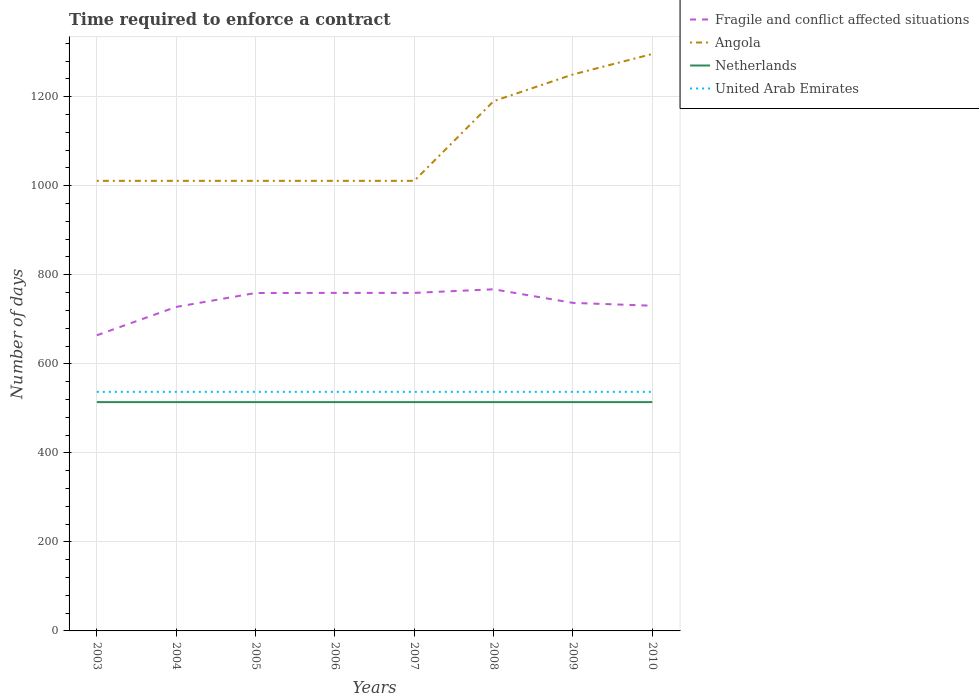Does the line corresponding to Angola intersect with the line corresponding to United Arab Emirates?
Keep it short and to the point. No. Is the number of lines equal to the number of legend labels?
Offer a terse response. Yes. Across all years, what is the maximum number of days required to enforce a contract in Fragile and conflict affected situations?
Offer a terse response. 664.11. What is the total number of days required to enforce a contract in Angola in the graph?
Your answer should be very brief. -60. Does the graph contain any zero values?
Ensure brevity in your answer.  No. Does the graph contain grids?
Give a very brief answer. Yes. Where does the legend appear in the graph?
Your response must be concise. Top right. How many legend labels are there?
Provide a short and direct response. 4. How are the legend labels stacked?
Offer a terse response. Vertical. What is the title of the graph?
Your response must be concise. Time required to enforce a contract. Does "Estonia" appear as one of the legend labels in the graph?
Ensure brevity in your answer.  No. What is the label or title of the Y-axis?
Offer a terse response. Number of days. What is the Number of days of Fragile and conflict affected situations in 2003?
Offer a terse response. 664.11. What is the Number of days in Angola in 2003?
Give a very brief answer. 1011. What is the Number of days of Netherlands in 2003?
Give a very brief answer. 514. What is the Number of days in United Arab Emirates in 2003?
Keep it short and to the point. 537. What is the Number of days of Fragile and conflict affected situations in 2004?
Make the answer very short. 727.8. What is the Number of days in Angola in 2004?
Make the answer very short. 1011. What is the Number of days in Netherlands in 2004?
Make the answer very short. 514. What is the Number of days of United Arab Emirates in 2004?
Give a very brief answer. 537. What is the Number of days in Fragile and conflict affected situations in 2005?
Provide a short and direct response. 759.07. What is the Number of days of Angola in 2005?
Your answer should be very brief. 1011. What is the Number of days in Netherlands in 2005?
Keep it short and to the point. 514. What is the Number of days in United Arab Emirates in 2005?
Ensure brevity in your answer.  537. What is the Number of days of Fragile and conflict affected situations in 2006?
Offer a very short reply. 759.34. What is the Number of days of Angola in 2006?
Your response must be concise. 1011. What is the Number of days of Netherlands in 2006?
Offer a terse response. 514. What is the Number of days of United Arab Emirates in 2006?
Offer a terse response. 537. What is the Number of days in Fragile and conflict affected situations in 2007?
Your response must be concise. 759.34. What is the Number of days of Angola in 2007?
Provide a succinct answer. 1011. What is the Number of days in Netherlands in 2007?
Your response must be concise. 514. What is the Number of days in United Arab Emirates in 2007?
Keep it short and to the point. 537. What is the Number of days in Fragile and conflict affected situations in 2008?
Provide a short and direct response. 767.41. What is the Number of days of Angola in 2008?
Offer a terse response. 1190. What is the Number of days in Netherlands in 2008?
Your answer should be compact. 514. What is the Number of days in United Arab Emirates in 2008?
Your response must be concise. 537. What is the Number of days in Fragile and conflict affected situations in 2009?
Offer a terse response. 736.87. What is the Number of days in Angola in 2009?
Offer a terse response. 1250. What is the Number of days in Netherlands in 2009?
Keep it short and to the point. 514. What is the Number of days in United Arab Emirates in 2009?
Make the answer very short. 537. What is the Number of days of Fragile and conflict affected situations in 2010?
Ensure brevity in your answer.  730.5. What is the Number of days of Angola in 2010?
Your answer should be compact. 1296. What is the Number of days of Netherlands in 2010?
Keep it short and to the point. 514. What is the Number of days of United Arab Emirates in 2010?
Make the answer very short. 537. Across all years, what is the maximum Number of days of Fragile and conflict affected situations?
Make the answer very short. 767.41. Across all years, what is the maximum Number of days of Angola?
Keep it short and to the point. 1296. Across all years, what is the maximum Number of days of Netherlands?
Provide a succinct answer. 514. Across all years, what is the maximum Number of days in United Arab Emirates?
Make the answer very short. 537. Across all years, what is the minimum Number of days in Fragile and conflict affected situations?
Provide a succinct answer. 664.11. Across all years, what is the minimum Number of days in Angola?
Your answer should be very brief. 1011. Across all years, what is the minimum Number of days in Netherlands?
Your response must be concise. 514. Across all years, what is the minimum Number of days of United Arab Emirates?
Ensure brevity in your answer.  537. What is the total Number of days of Fragile and conflict affected situations in the graph?
Provide a succinct answer. 5904.45. What is the total Number of days of Angola in the graph?
Keep it short and to the point. 8791. What is the total Number of days in Netherlands in the graph?
Make the answer very short. 4112. What is the total Number of days of United Arab Emirates in the graph?
Offer a very short reply. 4296. What is the difference between the Number of days of Fragile and conflict affected situations in 2003 and that in 2004?
Offer a terse response. -63.69. What is the difference between the Number of days of Angola in 2003 and that in 2004?
Give a very brief answer. 0. What is the difference between the Number of days of Fragile and conflict affected situations in 2003 and that in 2005?
Provide a short and direct response. -94.97. What is the difference between the Number of days of Angola in 2003 and that in 2005?
Offer a very short reply. 0. What is the difference between the Number of days in Netherlands in 2003 and that in 2005?
Your response must be concise. 0. What is the difference between the Number of days in Fragile and conflict affected situations in 2003 and that in 2006?
Make the answer very short. -95.24. What is the difference between the Number of days in Angola in 2003 and that in 2006?
Keep it short and to the point. 0. What is the difference between the Number of days of Netherlands in 2003 and that in 2006?
Ensure brevity in your answer.  0. What is the difference between the Number of days in United Arab Emirates in 2003 and that in 2006?
Provide a short and direct response. 0. What is the difference between the Number of days of Fragile and conflict affected situations in 2003 and that in 2007?
Give a very brief answer. -95.24. What is the difference between the Number of days of Netherlands in 2003 and that in 2007?
Provide a short and direct response. 0. What is the difference between the Number of days in United Arab Emirates in 2003 and that in 2007?
Your answer should be compact. 0. What is the difference between the Number of days in Fragile and conflict affected situations in 2003 and that in 2008?
Offer a very short reply. -103.31. What is the difference between the Number of days in Angola in 2003 and that in 2008?
Make the answer very short. -179. What is the difference between the Number of days in United Arab Emirates in 2003 and that in 2008?
Offer a terse response. 0. What is the difference between the Number of days in Fragile and conflict affected situations in 2003 and that in 2009?
Your answer should be compact. -72.76. What is the difference between the Number of days of Angola in 2003 and that in 2009?
Your answer should be very brief. -239. What is the difference between the Number of days of Netherlands in 2003 and that in 2009?
Offer a terse response. 0. What is the difference between the Number of days in Fragile and conflict affected situations in 2003 and that in 2010?
Offer a very short reply. -66.39. What is the difference between the Number of days of Angola in 2003 and that in 2010?
Offer a terse response. -285. What is the difference between the Number of days of Netherlands in 2003 and that in 2010?
Keep it short and to the point. 0. What is the difference between the Number of days in Fragile and conflict affected situations in 2004 and that in 2005?
Keep it short and to the point. -31.27. What is the difference between the Number of days of Fragile and conflict affected situations in 2004 and that in 2006?
Offer a very short reply. -31.54. What is the difference between the Number of days in Angola in 2004 and that in 2006?
Make the answer very short. 0. What is the difference between the Number of days of Fragile and conflict affected situations in 2004 and that in 2007?
Keep it short and to the point. -31.54. What is the difference between the Number of days in Angola in 2004 and that in 2007?
Keep it short and to the point. 0. What is the difference between the Number of days of United Arab Emirates in 2004 and that in 2007?
Your answer should be very brief. 0. What is the difference between the Number of days of Fragile and conflict affected situations in 2004 and that in 2008?
Keep it short and to the point. -39.61. What is the difference between the Number of days of Angola in 2004 and that in 2008?
Ensure brevity in your answer.  -179. What is the difference between the Number of days of Netherlands in 2004 and that in 2008?
Make the answer very short. 0. What is the difference between the Number of days of United Arab Emirates in 2004 and that in 2008?
Make the answer very short. 0. What is the difference between the Number of days in Fragile and conflict affected situations in 2004 and that in 2009?
Your response must be concise. -9.07. What is the difference between the Number of days of Angola in 2004 and that in 2009?
Offer a terse response. -239. What is the difference between the Number of days of Netherlands in 2004 and that in 2009?
Provide a short and direct response. 0. What is the difference between the Number of days of United Arab Emirates in 2004 and that in 2009?
Provide a succinct answer. 0. What is the difference between the Number of days in Angola in 2004 and that in 2010?
Provide a short and direct response. -285. What is the difference between the Number of days of United Arab Emirates in 2004 and that in 2010?
Give a very brief answer. 0. What is the difference between the Number of days in Fragile and conflict affected situations in 2005 and that in 2006?
Make the answer very short. -0.27. What is the difference between the Number of days of Netherlands in 2005 and that in 2006?
Provide a succinct answer. 0. What is the difference between the Number of days in United Arab Emirates in 2005 and that in 2006?
Provide a succinct answer. 0. What is the difference between the Number of days of Fragile and conflict affected situations in 2005 and that in 2007?
Make the answer very short. -0.27. What is the difference between the Number of days in Angola in 2005 and that in 2007?
Make the answer very short. 0. What is the difference between the Number of days of Netherlands in 2005 and that in 2007?
Your answer should be very brief. 0. What is the difference between the Number of days in Fragile and conflict affected situations in 2005 and that in 2008?
Your answer should be compact. -8.34. What is the difference between the Number of days of Angola in 2005 and that in 2008?
Keep it short and to the point. -179. What is the difference between the Number of days of Fragile and conflict affected situations in 2005 and that in 2009?
Give a very brief answer. 22.2. What is the difference between the Number of days of Angola in 2005 and that in 2009?
Offer a very short reply. -239. What is the difference between the Number of days in Netherlands in 2005 and that in 2009?
Give a very brief answer. 0. What is the difference between the Number of days in United Arab Emirates in 2005 and that in 2009?
Provide a short and direct response. 0. What is the difference between the Number of days in Fragile and conflict affected situations in 2005 and that in 2010?
Make the answer very short. 28.57. What is the difference between the Number of days of Angola in 2005 and that in 2010?
Your response must be concise. -285. What is the difference between the Number of days of Angola in 2006 and that in 2007?
Offer a very short reply. 0. What is the difference between the Number of days of Fragile and conflict affected situations in 2006 and that in 2008?
Your answer should be very brief. -8.07. What is the difference between the Number of days of Angola in 2006 and that in 2008?
Your response must be concise. -179. What is the difference between the Number of days of United Arab Emirates in 2006 and that in 2008?
Your answer should be compact. 0. What is the difference between the Number of days of Fragile and conflict affected situations in 2006 and that in 2009?
Make the answer very short. 22.48. What is the difference between the Number of days in Angola in 2006 and that in 2009?
Provide a short and direct response. -239. What is the difference between the Number of days in United Arab Emirates in 2006 and that in 2009?
Offer a very short reply. 0. What is the difference between the Number of days of Fragile and conflict affected situations in 2006 and that in 2010?
Offer a very short reply. 28.84. What is the difference between the Number of days in Angola in 2006 and that in 2010?
Your answer should be very brief. -285. What is the difference between the Number of days of Fragile and conflict affected situations in 2007 and that in 2008?
Provide a short and direct response. -8.07. What is the difference between the Number of days in Angola in 2007 and that in 2008?
Provide a short and direct response. -179. What is the difference between the Number of days of Netherlands in 2007 and that in 2008?
Your answer should be very brief. 0. What is the difference between the Number of days in Fragile and conflict affected situations in 2007 and that in 2009?
Your answer should be compact. 22.48. What is the difference between the Number of days of Angola in 2007 and that in 2009?
Your answer should be very brief. -239. What is the difference between the Number of days of Netherlands in 2007 and that in 2009?
Ensure brevity in your answer.  0. What is the difference between the Number of days in Fragile and conflict affected situations in 2007 and that in 2010?
Ensure brevity in your answer.  28.84. What is the difference between the Number of days of Angola in 2007 and that in 2010?
Offer a very short reply. -285. What is the difference between the Number of days in Fragile and conflict affected situations in 2008 and that in 2009?
Your response must be concise. 30.55. What is the difference between the Number of days in Angola in 2008 and that in 2009?
Ensure brevity in your answer.  -60. What is the difference between the Number of days of Netherlands in 2008 and that in 2009?
Make the answer very short. 0. What is the difference between the Number of days of Fragile and conflict affected situations in 2008 and that in 2010?
Your response must be concise. 36.91. What is the difference between the Number of days in Angola in 2008 and that in 2010?
Offer a very short reply. -106. What is the difference between the Number of days in United Arab Emirates in 2008 and that in 2010?
Your response must be concise. 0. What is the difference between the Number of days in Fragile and conflict affected situations in 2009 and that in 2010?
Give a very brief answer. 6.37. What is the difference between the Number of days in Angola in 2009 and that in 2010?
Make the answer very short. -46. What is the difference between the Number of days in Fragile and conflict affected situations in 2003 and the Number of days in Angola in 2004?
Your answer should be very brief. -346.89. What is the difference between the Number of days in Fragile and conflict affected situations in 2003 and the Number of days in Netherlands in 2004?
Offer a terse response. 150.11. What is the difference between the Number of days in Fragile and conflict affected situations in 2003 and the Number of days in United Arab Emirates in 2004?
Keep it short and to the point. 127.11. What is the difference between the Number of days in Angola in 2003 and the Number of days in Netherlands in 2004?
Your answer should be very brief. 497. What is the difference between the Number of days of Angola in 2003 and the Number of days of United Arab Emirates in 2004?
Make the answer very short. 474. What is the difference between the Number of days of Netherlands in 2003 and the Number of days of United Arab Emirates in 2004?
Ensure brevity in your answer.  -23. What is the difference between the Number of days of Fragile and conflict affected situations in 2003 and the Number of days of Angola in 2005?
Keep it short and to the point. -346.89. What is the difference between the Number of days in Fragile and conflict affected situations in 2003 and the Number of days in Netherlands in 2005?
Ensure brevity in your answer.  150.11. What is the difference between the Number of days in Fragile and conflict affected situations in 2003 and the Number of days in United Arab Emirates in 2005?
Offer a very short reply. 127.11. What is the difference between the Number of days of Angola in 2003 and the Number of days of Netherlands in 2005?
Provide a short and direct response. 497. What is the difference between the Number of days in Angola in 2003 and the Number of days in United Arab Emirates in 2005?
Ensure brevity in your answer.  474. What is the difference between the Number of days of Fragile and conflict affected situations in 2003 and the Number of days of Angola in 2006?
Give a very brief answer. -346.89. What is the difference between the Number of days of Fragile and conflict affected situations in 2003 and the Number of days of Netherlands in 2006?
Your response must be concise. 150.11. What is the difference between the Number of days in Fragile and conflict affected situations in 2003 and the Number of days in United Arab Emirates in 2006?
Give a very brief answer. 127.11. What is the difference between the Number of days in Angola in 2003 and the Number of days in Netherlands in 2006?
Offer a very short reply. 497. What is the difference between the Number of days in Angola in 2003 and the Number of days in United Arab Emirates in 2006?
Ensure brevity in your answer.  474. What is the difference between the Number of days of Netherlands in 2003 and the Number of days of United Arab Emirates in 2006?
Keep it short and to the point. -23. What is the difference between the Number of days of Fragile and conflict affected situations in 2003 and the Number of days of Angola in 2007?
Your answer should be compact. -346.89. What is the difference between the Number of days in Fragile and conflict affected situations in 2003 and the Number of days in Netherlands in 2007?
Your response must be concise. 150.11. What is the difference between the Number of days of Fragile and conflict affected situations in 2003 and the Number of days of United Arab Emirates in 2007?
Your answer should be compact. 127.11. What is the difference between the Number of days of Angola in 2003 and the Number of days of Netherlands in 2007?
Offer a very short reply. 497. What is the difference between the Number of days of Angola in 2003 and the Number of days of United Arab Emirates in 2007?
Your answer should be very brief. 474. What is the difference between the Number of days of Fragile and conflict affected situations in 2003 and the Number of days of Angola in 2008?
Make the answer very short. -525.89. What is the difference between the Number of days of Fragile and conflict affected situations in 2003 and the Number of days of Netherlands in 2008?
Offer a very short reply. 150.11. What is the difference between the Number of days of Fragile and conflict affected situations in 2003 and the Number of days of United Arab Emirates in 2008?
Give a very brief answer. 127.11. What is the difference between the Number of days of Angola in 2003 and the Number of days of Netherlands in 2008?
Your answer should be compact. 497. What is the difference between the Number of days in Angola in 2003 and the Number of days in United Arab Emirates in 2008?
Keep it short and to the point. 474. What is the difference between the Number of days in Netherlands in 2003 and the Number of days in United Arab Emirates in 2008?
Make the answer very short. -23. What is the difference between the Number of days of Fragile and conflict affected situations in 2003 and the Number of days of Angola in 2009?
Offer a terse response. -585.89. What is the difference between the Number of days in Fragile and conflict affected situations in 2003 and the Number of days in Netherlands in 2009?
Offer a terse response. 150.11. What is the difference between the Number of days of Fragile and conflict affected situations in 2003 and the Number of days of United Arab Emirates in 2009?
Give a very brief answer. 127.11. What is the difference between the Number of days of Angola in 2003 and the Number of days of Netherlands in 2009?
Keep it short and to the point. 497. What is the difference between the Number of days of Angola in 2003 and the Number of days of United Arab Emirates in 2009?
Give a very brief answer. 474. What is the difference between the Number of days in Netherlands in 2003 and the Number of days in United Arab Emirates in 2009?
Give a very brief answer. -23. What is the difference between the Number of days in Fragile and conflict affected situations in 2003 and the Number of days in Angola in 2010?
Keep it short and to the point. -631.89. What is the difference between the Number of days of Fragile and conflict affected situations in 2003 and the Number of days of Netherlands in 2010?
Keep it short and to the point. 150.11. What is the difference between the Number of days of Fragile and conflict affected situations in 2003 and the Number of days of United Arab Emirates in 2010?
Offer a very short reply. 127.11. What is the difference between the Number of days of Angola in 2003 and the Number of days of Netherlands in 2010?
Your answer should be very brief. 497. What is the difference between the Number of days of Angola in 2003 and the Number of days of United Arab Emirates in 2010?
Offer a very short reply. 474. What is the difference between the Number of days in Fragile and conflict affected situations in 2004 and the Number of days in Angola in 2005?
Offer a very short reply. -283.2. What is the difference between the Number of days of Fragile and conflict affected situations in 2004 and the Number of days of Netherlands in 2005?
Provide a succinct answer. 213.8. What is the difference between the Number of days in Fragile and conflict affected situations in 2004 and the Number of days in United Arab Emirates in 2005?
Offer a very short reply. 190.8. What is the difference between the Number of days in Angola in 2004 and the Number of days in Netherlands in 2005?
Your answer should be very brief. 497. What is the difference between the Number of days of Angola in 2004 and the Number of days of United Arab Emirates in 2005?
Your response must be concise. 474. What is the difference between the Number of days of Fragile and conflict affected situations in 2004 and the Number of days of Angola in 2006?
Your response must be concise. -283.2. What is the difference between the Number of days of Fragile and conflict affected situations in 2004 and the Number of days of Netherlands in 2006?
Offer a very short reply. 213.8. What is the difference between the Number of days of Fragile and conflict affected situations in 2004 and the Number of days of United Arab Emirates in 2006?
Provide a short and direct response. 190.8. What is the difference between the Number of days in Angola in 2004 and the Number of days in Netherlands in 2006?
Provide a short and direct response. 497. What is the difference between the Number of days of Angola in 2004 and the Number of days of United Arab Emirates in 2006?
Your answer should be compact. 474. What is the difference between the Number of days of Fragile and conflict affected situations in 2004 and the Number of days of Angola in 2007?
Provide a short and direct response. -283.2. What is the difference between the Number of days in Fragile and conflict affected situations in 2004 and the Number of days in Netherlands in 2007?
Provide a short and direct response. 213.8. What is the difference between the Number of days of Fragile and conflict affected situations in 2004 and the Number of days of United Arab Emirates in 2007?
Offer a very short reply. 190.8. What is the difference between the Number of days of Angola in 2004 and the Number of days of Netherlands in 2007?
Your answer should be very brief. 497. What is the difference between the Number of days in Angola in 2004 and the Number of days in United Arab Emirates in 2007?
Make the answer very short. 474. What is the difference between the Number of days of Netherlands in 2004 and the Number of days of United Arab Emirates in 2007?
Offer a terse response. -23. What is the difference between the Number of days of Fragile and conflict affected situations in 2004 and the Number of days of Angola in 2008?
Provide a succinct answer. -462.2. What is the difference between the Number of days in Fragile and conflict affected situations in 2004 and the Number of days in Netherlands in 2008?
Your answer should be very brief. 213.8. What is the difference between the Number of days in Fragile and conflict affected situations in 2004 and the Number of days in United Arab Emirates in 2008?
Offer a very short reply. 190.8. What is the difference between the Number of days of Angola in 2004 and the Number of days of Netherlands in 2008?
Your answer should be compact. 497. What is the difference between the Number of days in Angola in 2004 and the Number of days in United Arab Emirates in 2008?
Keep it short and to the point. 474. What is the difference between the Number of days of Fragile and conflict affected situations in 2004 and the Number of days of Angola in 2009?
Your response must be concise. -522.2. What is the difference between the Number of days of Fragile and conflict affected situations in 2004 and the Number of days of Netherlands in 2009?
Your answer should be very brief. 213.8. What is the difference between the Number of days in Fragile and conflict affected situations in 2004 and the Number of days in United Arab Emirates in 2009?
Your response must be concise. 190.8. What is the difference between the Number of days in Angola in 2004 and the Number of days in Netherlands in 2009?
Your answer should be very brief. 497. What is the difference between the Number of days in Angola in 2004 and the Number of days in United Arab Emirates in 2009?
Your response must be concise. 474. What is the difference between the Number of days in Fragile and conflict affected situations in 2004 and the Number of days in Angola in 2010?
Your response must be concise. -568.2. What is the difference between the Number of days of Fragile and conflict affected situations in 2004 and the Number of days of Netherlands in 2010?
Provide a succinct answer. 213.8. What is the difference between the Number of days in Fragile and conflict affected situations in 2004 and the Number of days in United Arab Emirates in 2010?
Your answer should be very brief. 190.8. What is the difference between the Number of days in Angola in 2004 and the Number of days in Netherlands in 2010?
Keep it short and to the point. 497. What is the difference between the Number of days in Angola in 2004 and the Number of days in United Arab Emirates in 2010?
Offer a terse response. 474. What is the difference between the Number of days of Netherlands in 2004 and the Number of days of United Arab Emirates in 2010?
Keep it short and to the point. -23. What is the difference between the Number of days in Fragile and conflict affected situations in 2005 and the Number of days in Angola in 2006?
Offer a very short reply. -251.93. What is the difference between the Number of days of Fragile and conflict affected situations in 2005 and the Number of days of Netherlands in 2006?
Your answer should be compact. 245.07. What is the difference between the Number of days in Fragile and conflict affected situations in 2005 and the Number of days in United Arab Emirates in 2006?
Offer a terse response. 222.07. What is the difference between the Number of days of Angola in 2005 and the Number of days of Netherlands in 2006?
Give a very brief answer. 497. What is the difference between the Number of days of Angola in 2005 and the Number of days of United Arab Emirates in 2006?
Give a very brief answer. 474. What is the difference between the Number of days of Netherlands in 2005 and the Number of days of United Arab Emirates in 2006?
Provide a short and direct response. -23. What is the difference between the Number of days in Fragile and conflict affected situations in 2005 and the Number of days in Angola in 2007?
Provide a short and direct response. -251.93. What is the difference between the Number of days of Fragile and conflict affected situations in 2005 and the Number of days of Netherlands in 2007?
Ensure brevity in your answer.  245.07. What is the difference between the Number of days of Fragile and conflict affected situations in 2005 and the Number of days of United Arab Emirates in 2007?
Provide a short and direct response. 222.07. What is the difference between the Number of days of Angola in 2005 and the Number of days of Netherlands in 2007?
Your answer should be very brief. 497. What is the difference between the Number of days in Angola in 2005 and the Number of days in United Arab Emirates in 2007?
Provide a succinct answer. 474. What is the difference between the Number of days of Fragile and conflict affected situations in 2005 and the Number of days of Angola in 2008?
Ensure brevity in your answer.  -430.93. What is the difference between the Number of days in Fragile and conflict affected situations in 2005 and the Number of days in Netherlands in 2008?
Your answer should be compact. 245.07. What is the difference between the Number of days of Fragile and conflict affected situations in 2005 and the Number of days of United Arab Emirates in 2008?
Offer a very short reply. 222.07. What is the difference between the Number of days of Angola in 2005 and the Number of days of Netherlands in 2008?
Provide a succinct answer. 497. What is the difference between the Number of days in Angola in 2005 and the Number of days in United Arab Emirates in 2008?
Give a very brief answer. 474. What is the difference between the Number of days of Netherlands in 2005 and the Number of days of United Arab Emirates in 2008?
Provide a succinct answer. -23. What is the difference between the Number of days of Fragile and conflict affected situations in 2005 and the Number of days of Angola in 2009?
Your response must be concise. -490.93. What is the difference between the Number of days in Fragile and conflict affected situations in 2005 and the Number of days in Netherlands in 2009?
Your answer should be compact. 245.07. What is the difference between the Number of days in Fragile and conflict affected situations in 2005 and the Number of days in United Arab Emirates in 2009?
Keep it short and to the point. 222.07. What is the difference between the Number of days in Angola in 2005 and the Number of days in Netherlands in 2009?
Provide a succinct answer. 497. What is the difference between the Number of days in Angola in 2005 and the Number of days in United Arab Emirates in 2009?
Your answer should be compact. 474. What is the difference between the Number of days in Netherlands in 2005 and the Number of days in United Arab Emirates in 2009?
Ensure brevity in your answer.  -23. What is the difference between the Number of days in Fragile and conflict affected situations in 2005 and the Number of days in Angola in 2010?
Your answer should be very brief. -536.93. What is the difference between the Number of days in Fragile and conflict affected situations in 2005 and the Number of days in Netherlands in 2010?
Provide a succinct answer. 245.07. What is the difference between the Number of days of Fragile and conflict affected situations in 2005 and the Number of days of United Arab Emirates in 2010?
Offer a terse response. 222.07. What is the difference between the Number of days in Angola in 2005 and the Number of days in Netherlands in 2010?
Your answer should be very brief. 497. What is the difference between the Number of days in Angola in 2005 and the Number of days in United Arab Emirates in 2010?
Your answer should be very brief. 474. What is the difference between the Number of days in Netherlands in 2005 and the Number of days in United Arab Emirates in 2010?
Give a very brief answer. -23. What is the difference between the Number of days in Fragile and conflict affected situations in 2006 and the Number of days in Angola in 2007?
Provide a succinct answer. -251.66. What is the difference between the Number of days in Fragile and conflict affected situations in 2006 and the Number of days in Netherlands in 2007?
Offer a very short reply. 245.34. What is the difference between the Number of days of Fragile and conflict affected situations in 2006 and the Number of days of United Arab Emirates in 2007?
Your answer should be very brief. 222.34. What is the difference between the Number of days in Angola in 2006 and the Number of days in Netherlands in 2007?
Offer a terse response. 497. What is the difference between the Number of days in Angola in 2006 and the Number of days in United Arab Emirates in 2007?
Keep it short and to the point. 474. What is the difference between the Number of days in Netherlands in 2006 and the Number of days in United Arab Emirates in 2007?
Keep it short and to the point. -23. What is the difference between the Number of days in Fragile and conflict affected situations in 2006 and the Number of days in Angola in 2008?
Your answer should be compact. -430.66. What is the difference between the Number of days of Fragile and conflict affected situations in 2006 and the Number of days of Netherlands in 2008?
Offer a terse response. 245.34. What is the difference between the Number of days of Fragile and conflict affected situations in 2006 and the Number of days of United Arab Emirates in 2008?
Give a very brief answer. 222.34. What is the difference between the Number of days in Angola in 2006 and the Number of days in Netherlands in 2008?
Make the answer very short. 497. What is the difference between the Number of days of Angola in 2006 and the Number of days of United Arab Emirates in 2008?
Give a very brief answer. 474. What is the difference between the Number of days in Fragile and conflict affected situations in 2006 and the Number of days in Angola in 2009?
Give a very brief answer. -490.66. What is the difference between the Number of days in Fragile and conflict affected situations in 2006 and the Number of days in Netherlands in 2009?
Make the answer very short. 245.34. What is the difference between the Number of days of Fragile and conflict affected situations in 2006 and the Number of days of United Arab Emirates in 2009?
Ensure brevity in your answer.  222.34. What is the difference between the Number of days in Angola in 2006 and the Number of days in Netherlands in 2009?
Offer a very short reply. 497. What is the difference between the Number of days of Angola in 2006 and the Number of days of United Arab Emirates in 2009?
Give a very brief answer. 474. What is the difference between the Number of days in Fragile and conflict affected situations in 2006 and the Number of days in Angola in 2010?
Your response must be concise. -536.66. What is the difference between the Number of days of Fragile and conflict affected situations in 2006 and the Number of days of Netherlands in 2010?
Ensure brevity in your answer.  245.34. What is the difference between the Number of days of Fragile and conflict affected situations in 2006 and the Number of days of United Arab Emirates in 2010?
Your answer should be very brief. 222.34. What is the difference between the Number of days in Angola in 2006 and the Number of days in Netherlands in 2010?
Offer a very short reply. 497. What is the difference between the Number of days of Angola in 2006 and the Number of days of United Arab Emirates in 2010?
Provide a succinct answer. 474. What is the difference between the Number of days in Netherlands in 2006 and the Number of days in United Arab Emirates in 2010?
Make the answer very short. -23. What is the difference between the Number of days in Fragile and conflict affected situations in 2007 and the Number of days in Angola in 2008?
Offer a terse response. -430.66. What is the difference between the Number of days of Fragile and conflict affected situations in 2007 and the Number of days of Netherlands in 2008?
Ensure brevity in your answer.  245.34. What is the difference between the Number of days of Fragile and conflict affected situations in 2007 and the Number of days of United Arab Emirates in 2008?
Your answer should be very brief. 222.34. What is the difference between the Number of days in Angola in 2007 and the Number of days in Netherlands in 2008?
Make the answer very short. 497. What is the difference between the Number of days of Angola in 2007 and the Number of days of United Arab Emirates in 2008?
Provide a short and direct response. 474. What is the difference between the Number of days of Netherlands in 2007 and the Number of days of United Arab Emirates in 2008?
Make the answer very short. -23. What is the difference between the Number of days in Fragile and conflict affected situations in 2007 and the Number of days in Angola in 2009?
Your answer should be very brief. -490.66. What is the difference between the Number of days of Fragile and conflict affected situations in 2007 and the Number of days of Netherlands in 2009?
Provide a succinct answer. 245.34. What is the difference between the Number of days in Fragile and conflict affected situations in 2007 and the Number of days in United Arab Emirates in 2009?
Offer a very short reply. 222.34. What is the difference between the Number of days in Angola in 2007 and the Number of days in Netherlands in 2009?
Keep it short and to the point. 497. What is the difference between the Number of days of Angola in 2007 and the Number of days of United Arab Emirates in 2009?
Ensure brevity in your answer.  474. What is the difference between the Number of days of Fragile and conflict affected situations in 2007 and the Number of days of Angola in 2010?
Ensure brevity in your answer.  -536.66. What is the difference between the Number of days in Fragile and conflict affected situations in 2007 and the Number of days in Netherlands in 2010?
Provide a succinct answer. 245.34. What is the difference between the Number of days of Fragile and conflict affected situations in 2007 and the Number of days of United Arab Emirates in 2010?
Provide a succinct answer. 222.34. What is the difference between the Number of days in Angola in 2007 and the Number of days in Netherlands in 2010?
Ensure brevity in your answer.  497. What is the difference between the Number of days in Angola in 2007 and the Number of days in United Arab Emirates in 2010?
Provide a short and direct response. 474. What is the difference between the Number of days of Netherlands in 2007 and the Number of days of United Arab Emirates in 2010?
Offer a very short reply. -23. What is the difference between the Number of days of Fragile and conflict affected situations in 2008 and the Number of days of Angola in 2009?
Make the answer very short. -482.59. What is the difference between the Number of days of Fragile and conflict affected situations in 2008 and the Number of days of Netherlands in 2009?
Give a very brief answer. 253.41. What is the difference between the Number of days of Fragile and conflict affected situations in 2008 and the Number of days of United Arab Emirates in 2009?
Keep it short and to the point. 230.41. What is the difference between the Number of days in Angola in 2008 and the Number of days in Netherlands in 2009?
Provide a succinct answer. 676. What is the difference between the Number of days in Angola in 2008 and the Number of days in United Arab Emirates in 2009?
Your response must be concise. 653. What is the difference between the Number of days of Fragile and conflict affected situations in 2008 and the Number of days of Angola in 2010?
Ensure brevity in your answer.  -528.59. What is the difference between the Number of days in Fragile and conflict affected situations in 2008 and the Number of days in Netherlands in 2010?
Ensure brevity in your answer.  253.41. What is the difference between the Number of days in Fragile and conflict affected situations in 2008 and the Number of days in United Arab Emirates in 2010?
Make the answer very short. 230.41. What is the difference between the Number of days in Angola in 2008 and the Number of days in Netherlands in 2010?
Your answer should be very brief. 676. What is the difference between the Number of days in Angola in 2008 and the Number of days in United Arab Emirates in 2010?
Keep it short and to the point. 653. What is the difference between the Number of days in Netherlands in 2008 and the Number of days in United Arab Emirates in 2010?
Provide a succinct answer. -23. What is the difference between the Number of days in Fragile and conflict affected situations in 2009 and the Number of days in Angola in 2010?
Your answer should be very brief. -559.13. What is the difference between the Number of days in Fragile and conflict affected situations in 2009 and the Number of days in Netherlands in 2010?
Offer a terse response. 222.87. What is the difference between the Number of days of Fragile and conflict affected situations in 2009 and the Number of days of United Arab Emirates in 2010?
Ensure brevity in your answer.  199.87. What is the difference between the Number of days of Angola in 2009 and the Number of days of Netherlands in 2010?
Give a very brief answer. 736. What is the difference between the Number of days of Angola in 2009 and the Number of days of United Arab Emirates in 2010?
Offer a terse response. 713. What is the difference between the Number of days in Netherlands in 2009 and the Number of days in United Arab Emirates in 2010?
Offer a very short reply. -23. What is the average Number of days of Fragile and conflict affected situations per year?
Give a very brief answer. 738.06. What is the average Number of days of Angola per year?
Give a very brief answer. 1098.88. What is the average Number of days of Netherlands per year?
Your response must be concise. 514. What is the average Number of days of United Arab Emirates per year?
Your answer should be compact. 537. In the year 2003, what is the difference between the Number of days of Fragile and conflict affected situations and Number of days of Angola?
Keep it short and to the point. -346.89. In the year 2003, what is the difference between the Number of days in Fragile and conflict affected situations and Number of days in Netherlands?
Offer a very short reply. 150.11. In the year 2003, what is the difference between the Number of days of Fragile and conflict affected situations and Number of days of United Arab Emirates?
Your answer should be very brief. 127.11. In the year 2003, what is the difference between the Number of days of Angola and Number of days of Netherlands?
Your response must be concise. 497. In the year 2003, what is the difference between the Number of days in Angola and Number of days in United Arab Emirates?
Keep it short and to the point. 474. In the year 2004, what is the difference between the Number of days in Fragile and conflict affected situations and Number of days in Angola?
Provide a succinct answer. -283.2. In the year 2004, what is the difference between the Number of days in Fragile and conflict affected situations and Number of days in Netherlands?
Your response must be concise. 213.8. In the year 2004, what is the difference between the Number of days of Fragile and conflict affected situations and Number of days of United Arab Emirates?
Give a very brief answer. 190.8. In the year 2004, what is the difference between the Number of days of Angola and Number of days of Netherlands?
Give a very brief answer. 497. In the year 2004, what is the difference between the Number of days in Angola and Number of days in United Arab Emirates?
Make the answer very short. 474. In the year 2005, what is the difference between the Number of days of Fragile and conflict affected situations and Number of days of Angola?
Provide a succinct answer. -251.93. In the year 2005, what is the difference between the Number of days of Fragile and conflict affected situations and Number of days of Netherlands?
Provide a short and direct response. 245.07. In the year 2005, what is the difference between the Number of days in Fragile and conflict affected situations and Number of days in United Arab Emirates?
Your answer should be very brief. 222.07. In the year 2005, what is the difference between the Number of days in Angola and Number of days in Netherlands?
Make the answer very short. 497. In the year 2005, what is the difference between the Number of days in Angola and Number of days in United Arab Emirates?
Ensure brevity in your answer.  474. In the year 2005, what is the difference between the Number of days of Netherlands and Number of days of United Arab Emirates?
Make the answer very short. -23. In the year 2006, what is the difference between the Number of days in Fragile and conflict affected situations and Number of days in Angola?
Give a very brief answer. -251.66. In the year 2006, what is the difference between the Number of days in Fragile and conflict affected situations and Number of days in Netherlands?
Offer a very short reply. 245.34. In the year 2006, what is the difference between the Number of days in Fragile and conflict affected situations and Number of days in United Arab Emirates?
Provide a succinct answer. 222.34. In the year 2006, what is the difference between the Number of days of Angola and Number of days of Netherlands?
Offer a very short reply. 497. In the year 2006, what is the difference between the Number of days in Angola and Number of days in United Arab Emirates?
Provide a succinct answer. 474. In the year 2007, what is the difference between the Number of days of Fragile and conflict affected situations and Number of days of Angola?
Your answer should be compact. -251.66. In the year 2007, what is the difference between the Number of days of Fragile and conflict affected situations and Number of days of Netherlands?
Offer a very short reply. 245.34. In the year 2007, what is the difference between the Number of days of Fragile and conflict affected situations and Number of days of United Arab Emirates?
Offer a terse response. 222.34. In the year 2007, what is the difference between the Number of days in Angola and Number of days in Netherlands?
Keep it short and to the point. 497. In the year 2007, what is the difference between the Number of days of Angola and Number of days of United Arab Emirates?
Ensure brevity in your answer.  474. In the year 2007, what is the difference between the Number of days of Netherlands and Number of days of United Arab Emirates?
Your answer should be very brief. -23. In the year 2008, what is the difference between the Number of days of Fragile and conflict affected situations and Number of days of Angola?
Your response must be concise. -422.59. In the year 2008, what is the difference between the Number of days of Fragile and conflict affected situations and Number of days of Netherlands?
Provide a short and direct response. 253.41. In the year 2008, what is the difference between the Number of days of Fragile and conflict affected situations and Number of days of United Arab Emirates?
Provide a short and direct response. 230.41. In the year 2008, what is the difference between the Number of days of Angola and Number of days of Netherlands?
Keep it short and to the point. 676. In the year 2008, what is the difference between the Number of days of Angola and Number of days of United Arab Emirates?
Provide a short and direct response. 653. In the year 2008, what is the difference between the Number of days in Netherlands and Number of days in United Arab Emirates?
Your answer should be very brief. -23. In the year 2009, what is the difference between the Number of days in Fragile and conflict affected situations and Number of days in Angola?
Make the answer very short. -513.13. In the year 2009, what is the difference between the Number of days of Fragile and conflict affected situations and Number of days of Netherlands?
Make the answer very short. 222.87. In the year 2009, what is the difference between the Number of days of Fragile and conflict affected situations and Number of days of United Arab Emirates?
Offer a terse response. 199.87. In the year 2009, what is the difference between the Number of days in Angola and Number of days in Netherlands?
Your answer should be compact. 736. In the year 2009, what is the difference between the Number of days of Angola and Number of days of United Arab Emirates?
Offer a very short reply. 713. In the year 2010, what is the difference between the Number of days in Fragile and conflict affected situations and Number of days in Angola?
Give a very brief answer. -565.5. In the year 2010, what is the difference between the Number of days of Fragile and conflict affected situations and Number of days of Netherlands?
Your answer should be very brief. 216.5. In the year 2010, what is the difference between the Number of days in Fragile and conflict affected situations and Number of days in United Arab Emirates?
Ensure brevity in your answer.  193.5. In the year 2010, what is the difference between the Number of days of Angola and Number of days of Netherlands?
Your answer should be compact. 782. In the year 2010, what is the difference between the Number of days of Angola and Number of days of United Arab Emirates?
Give a very brief answer. 759. In the year 2010, what is the difference between the Number of days of Netherlands and Number of days of United Arab Emirates?
Your answer should be compact. -23. What is the ratio of the Number of days in Fragile and conflict affected situations in 2003 to that in 2004?
Give a very brief answer. 0.91. What is the ratio of the Number of days in Angola in 2003 to that in 2004?
Offer a terse response. 1. What is the ratio of the Number of days in Netherlands in 2003 to that in 2004?
Your answer should be very brief. 1. What is the ratio of the Number of days in United Arab Emirates in 2003 to that in 2004?
Keep it short and to the point. 1. What is the ratio of the Number of days of Fragile and conflict affected situations in 2003 to that in 2005?
Offer a very short reply. 0.87. What is the ratio of the Number of days of United Arab Emirates in 2003 to that in 2005?
Offer a terse response. 1. What is the ratio of the Number of days of Fragile and conflict affected situations in 2003 to that in 2006?
Ensure brevity in your answer.  0.87. What is the ratio of the Number of days of Netherlands in 2003 to that in 2006?
Provide a short and direct response. 1. What is the ratio of the Number of days in Fragile and conflict affected situations in 2003 to that in 2007?
Offer a terse response. 0.87. What is the ratio of the Number of days of Netherlands in 2003 to that in 2007?
Give a very brief answer. 1. What is the ratio of the Number of days in Fragile and conflict affected situations in 2003 to that in 2008?
Your answer should be compact. 0.87. What is the ratio of the Number of days of Angola in 2003 to that in 2008?
Provide a succinct answer. 0.85. What is the ratio of the Number of days of Fragile and conflict affected situations in 2003 to that in 2009?
Keep it short and to the point. 0.9. What is the ratio of the Number of days in Angola in 2003 to that in 2009?
Offer a terse response. 0.81. What is the ratio of the Number of days of United Arab Emirates in 2003 to that in 2009?
Give a very brief answer. 1. What is the ratio of the Number of days in Angola in 2003 to that in 2010?
Ensure brevity in your answer.  0.78. What is the ratio of the Number of days in Fragile and conflict affected situations in 2004 to that in 2005?
Your answer should be compact. 0.96. What is the ratio of the Number of days of Angola in 2004 to that in 2005?
Give a very brief answer. 1. What is the ratio of the Number of days in Fragile and conflict affected situations in 2004 to that in 2006?
Offer a very short reply. 0.96. What is the ratio of the Number of days in United Arab Emirates in 2004 to that in 2006?
Provide a succinct answer. 1. What is the ratio of the Number of days in Fragile and conflict affected situations in 2004 to that in 2007?
Offer a terse response. 0.96. What is the ratio of the Number of days in Angola in 2004 to that in 2007?
Your response must be concise. 1. What is the ratio of the Number of days in Netherlands in 2004 to that in 2007?
Keep it short and to the point. 1. What is the ratio of the Number of days of Fragile and conflict affected situations in 2004 to that in 2008?
Your answer should be compact. 0.95. What is the ratio of the Number of days in Angola in 2004 to that in 2008?
Provide a succinct answer. 0.85. What is the ratio of the Number of days of Netherlands in 2004 to that in 2008?
Provide a short and direct response. 1. What is the ratio of the Number of days of United Arab Emirates in 2004 to that in 2008?
Make the answer very short. 1. What is the ratio of the Number of days in Fragile and conflict affected situations in 2004 to that in 2009?
Provide a short and direct response. 0.99. What is the ratio of the Number of days of Angola in 2004 to that in 2009?
Your answer should be compact. 0.81. What is the ratio of the Number of days in Netherlands in 2004 to that in 2009?
Keep it short and to the point. 1. What is the ratio of the Number of days in United Arab Emirates in 2004 to that in 2009?
Your response must be concise. 1. What is the ratio of the Number of days in Angola in 2004 to that in 2010?
Keep it short and to the point. 0.78. What is the ratio of the Number of days in United Arab Emirates in 2004 to that in 2010?
Provide a short and direct response. 1. What is the ratio of the Number of days of Angola in 2005 to that in 2006?
Your answer should be compact. 1. What is the ratio of the Number of days in United Arab Emirates in 2005 to that in 2006?
Provide a succinct answer. 1. What is the ratio of the Number of days in Fragile and conflict affected situations in 2005 to that in 2008?
Your answer should be compact. 0.99. What is the ratio of the Number of days of Angola in 2005 to that in 2008?
Provide a short and direct response. 0.85. What is the ratio of the Number of days of United Arab Emirates in 2005 to that in 2008?
Offer a very short reply. 1. What is the ratio of the Number of days in Fragile and conflict affected situations in 2005 to that in 2009?
Offer a very short reply. 1.03. What is the ratio of the Number of days of Angola in 2005 to that in 2009?
Ensure brevity in your answer.  0.81. What is the ratio of the Number of days in United Arab Emirates in 2005 to that in 2009?
Provide a succinct answer. 1. What is the ratio of the Number of days of Fragile and conflict affected situations in 2005 to that in 2010?
Ensure brevity in your answer.  1.04. What is the ratio of the Number of days of Angola in 2005 to that in 2010?
Ensure brevity in your answer.  0.78. What is the ratio of the Number of days in Netherlands in 2005 to that in 2010?
Provide a short and direct response. 1. What is the ratio of the Number of days of United Arab Emirates in 2005 to that in 2010?
Make the answer very short. 1. What is the ratio of the Number of days of United Arab Emirates in 2006 to that in 2007?
Your answer should be compact. 1. What is the ratio of the Number of days in Angola in 2006 to that in 2008?
Your answer should be very brief. 0.85. What is the ratio of the Number of days of Netherlands in 2006 to that in 2008?
Ensure brevity in your answer.  1. What is the ratio of the Number of days in United Arab Emirates in 2006 to that in 2008?
Give a very brief answer. 1. What is the ratio of the Number of days in Fragile and conflict affected situations in 2006 to that in 2009?
Make the answer very short. 1.03. What is the ratio of the Number of days in Angola in 2006 to that in 2009?
Keep it short and to the point. 0.81. What is the ratio of the Number of days of Netherlands in 2006 to that in 2009?
Offer a very short reply. 1. What is the ratio of the Number of days in United Arab Emirates in 2006 to that in 2009?
Provide a short and direct response. 1. What is the ratio of the Number of days in Fragile and conflict affected situations in 2006 to that in 2010?
Offer a terse response. 1.04. What is the ratio of the Number of days of Angola in 2006 to that in 2010?
Offer a very short reply. 0.78. What is the ratio of the Number of days of United Arab Emirates in 2006 to that in 2010?
Your answer should be compact. 1. What is the ratio of the Number of days in Fragile and conflict affected situations in 2007 to that in 2008?
Your answer should be very brief. 0.99. What is the ratio of the Number of days of Angola in 2007 to that in 2008?
Give a very brief answer. 0.85. What is the ratio of the Number of days in Netherlands in 2007 to that in 2008?
Ensure brevity in your answer.  1. What is the ratio of the Number of days of Fragile and conflict affected situations in 2007 to that in 2009?
Your answer should be very brief. 1.03. What is the ratio of the Number of days of Angola in 2007 to that in 2009?
Offer a terse response. 0.81. What is the ratio of the Number of days of Fragile and conflict affected situations in 2007 to that in 2010?
Your answer should be compact. 1.04. What is the ratio of the Number of days in Angola in 2007 to that in 2010?
Provide a short and direct response. 0.78. What is the ratio of the Number of days in Fragile and conflict affected situations in 2008 to that in 2009?
Ensure brevity in your answer.  1.04. What is the ratio of the Number of days in Netherlands in 2008 to that in 2009?
Give a very brief answer. 1. What is the ratio of the Number of days in United Arab Emirates in 2008 to that in 2009?
Give a very brief answer. 1. What is the ratio of the Number of days in Fragile and conflict affected situations in 2008 to that in 2010?
Keep it short and to the point. 1.05. What is the ratio of the Number of days of Angola in 2008 to that in 2010?
Make the answer very short. 0.92. What is the ratio of the Number of days in United Arab Emirates in 2008 to that in 2010?
Offer a very short reply. 1. What is the ratio of the Number of days of Fragile and conflict affected situations in 2009 to that in 2010?
Your answer should be compact. 1.01. What is the ratio of the Number of days of Angola in 2009 to that in 2010?
Ensure brevity in your answer.  0.96. What is the ratio of the Number of days of United Arab Emirates in 2009 to that in 2010?
Your response must be concise. 1. What is the difference between the highest and the second highest Number of days in Fragile and conflict affected situations?
Provide a succinct answer. 8.07. What is the difference between the highest and the second highest Number of days in Angola?
Your response must be concise. 46. What is the difference between the highest and the second highest Number of days in Netherlands?
Offer a terse response. 0. What is the difference between the highest and the second highest Number of days of United Arab Emirates?
Provide a short and direct response. 0. What is the difference between the highest and the lowest Number of days of Fragile and conflict affected situations?
Offer a terse response. 103.31. What is the difference between the highest and the lowest Number of days in Angola?
Ensure brevity in your answer.  285. What is the difference between the highest and the lowest Number of days in Netherlands?
Offer a very short reply. 0. 